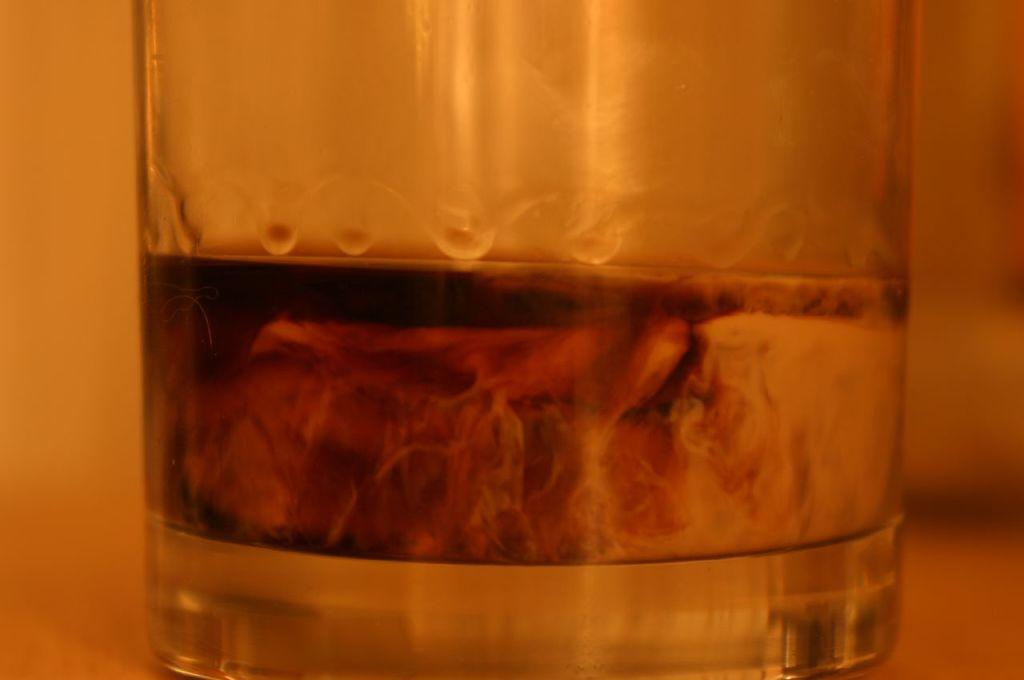What is inside the glass that is visible in the image? There is a liquid in the glass that is visible in the image. Where might the glass be placed in the image? The glass might be placed on a table in the image. What color is the background of the image? The background of the image is white. How is the background of the image depicted? The background of the image is blurred. What type of metal can be seen in the image? There is no metal present in the image. At what angle is the glass tilted in the image? The angle of the glass cannot be determined from the image, as it is not depicted in a way that shows its tilt. 